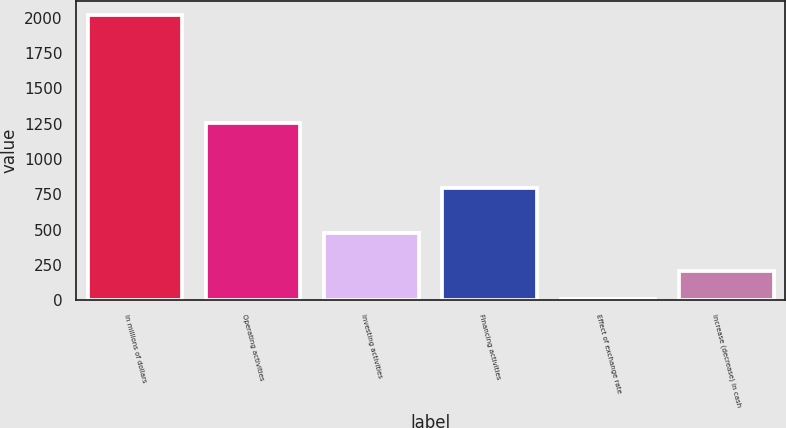<chart> <loc_0><loc_0><loc_500><loc_500><bar_chart><fcel>In millions of dollars<fcel>Operating activities<fcel>Investing activities<fcel>Financing activities<fcel>Effect of exchange rate<fcel>Increase (decrease) in cash<nl><fcel>2015<fcel>1256.3<fcel>477.2<fcel>797<fcel>10.4<fcel>210.86<nl></chart> 